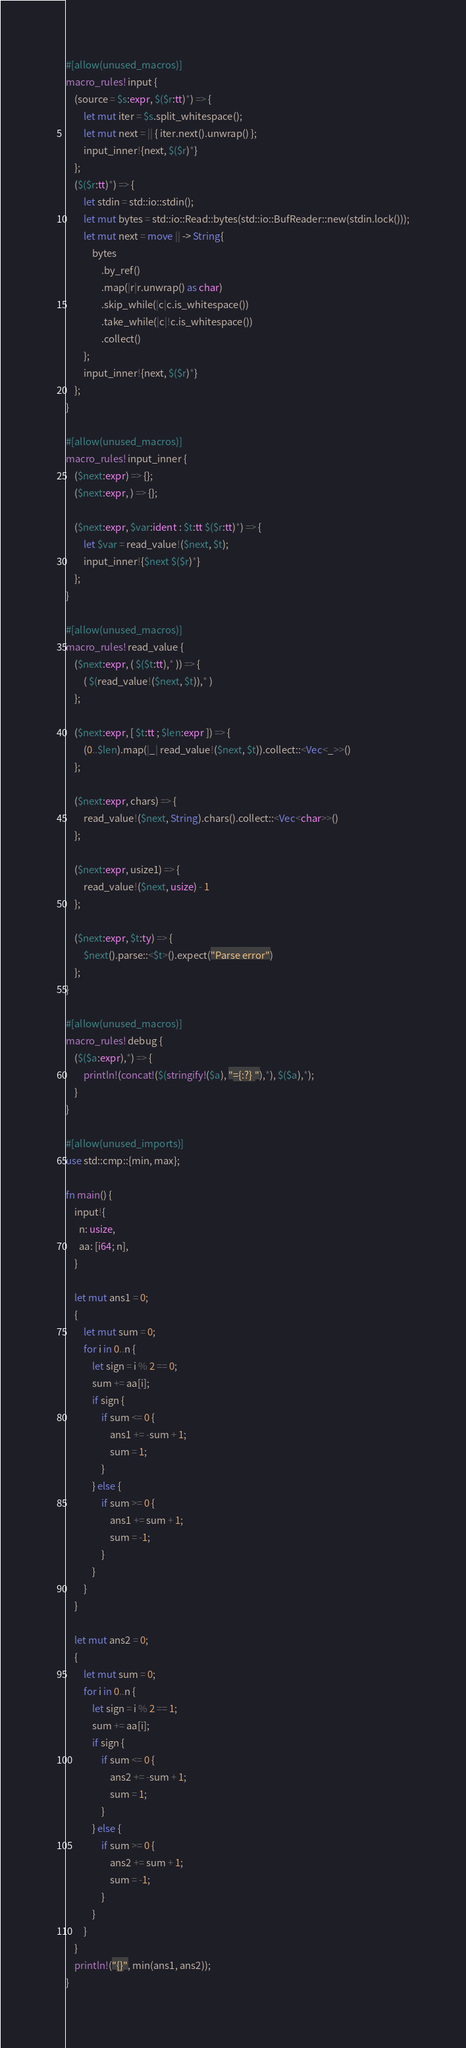<code> <loc_0><loc_0><loc_500><loc_500><_Rust_>#[allow(unused_macros)]
macro_rules! input {
    (source = $s:expr, $($r:tt)*) => {
        let mut iter = $s.split_whitespace();
        let mut next = || { iter.next().unwrap() };
        input_inner!{next, $($r)*}
    };
    ($($r:tt)*) => {
        let stdin = std::io::stdin();
        let mut bytes = std::io::Read::bytes(std::io::BufReader::new(stdin.lock()));
        let mut next = move || -> String{
            bytes
                .by_ref()
                .map(|r|r.unwrap() as char)
                .skip_while(|c|c.is_whitespace())
                .take_while(|c|!c.is_whitespace())
                .collect()
        };
        input_inner!{next, $($r)*}
    };
}

#[allow(unused_macros)]
macro_rules! input_inner {
    ($next:expr) => {};
    ($next:expr, ) => {};

    ($next:expr, $var:ident : $t:tt $($r:tt)*) => {
        let $var = read_value!($next, $t);
        input_inner!{$next $($r)*}
    };
}

#[allow(unused_macros)]
macro_rules! read_value {
    ($next:expr, ( $($t:tt),* )) => {
        ( $(read_value!($next, $t)),* )
    };

    ($next:expr, [ $t:tt ; $len:expr ]) => {
        (0..$len).map(|_| read_value!($next, $t)).collect::<Vec<_>>()
    };

    ($next:expr, chars) => {
        read_value!($next, String).chars().collect::<Vec<char>>()
    };

    ($next:expr, usize1) => {
        read_value!($next, usize) - 1
    };

    ($next:expr, $t:ty) => {
        $next().parse::<$t>().expect("Parse error")
    };
}

#[allow(unused_macros)]
macro_rules! debug {
    ($($a:expr),*) => {
        println!(concat!($(stringify!($a), "={:?} "),*), $($a),*);
    }
}

#[allow(unused_imports)]
use std::cmp::{min, max};

fn main() {
    input!{
      n: usize,
      aa: [i64; n],
    }

    let mut ans1 = 0;
    {
        let mut sum = 0;
        for i in 0..n {
            let sign = i % 2 == 0;
            sum += aa[i];
            if sign {
                if sum <= 0 {
                    ans1 += -sum + 1;
                    sum = 1;
                }
            } else {
                if sum >= 0 {
                    ans1 += sum + 1;
                    sum = -1;
                }
            }
        }
    }

    let mut ans2 = 0;
    {
        let mut sum = 0;
        for i in 0..n {
            let sign = i % 2 == 1;
            sum += aa[i];
            if sign {
                if sum <= 0 {
                    ans2 += -sum + 1;
                    sum = 1;
                }
            } else {
                if sum >= 0 {
                    ans2 += sum + 1;
                    sum = -1;
                }
            }
        }
    }
    println!("{}", min(ans1, ans2));
}
</code> 